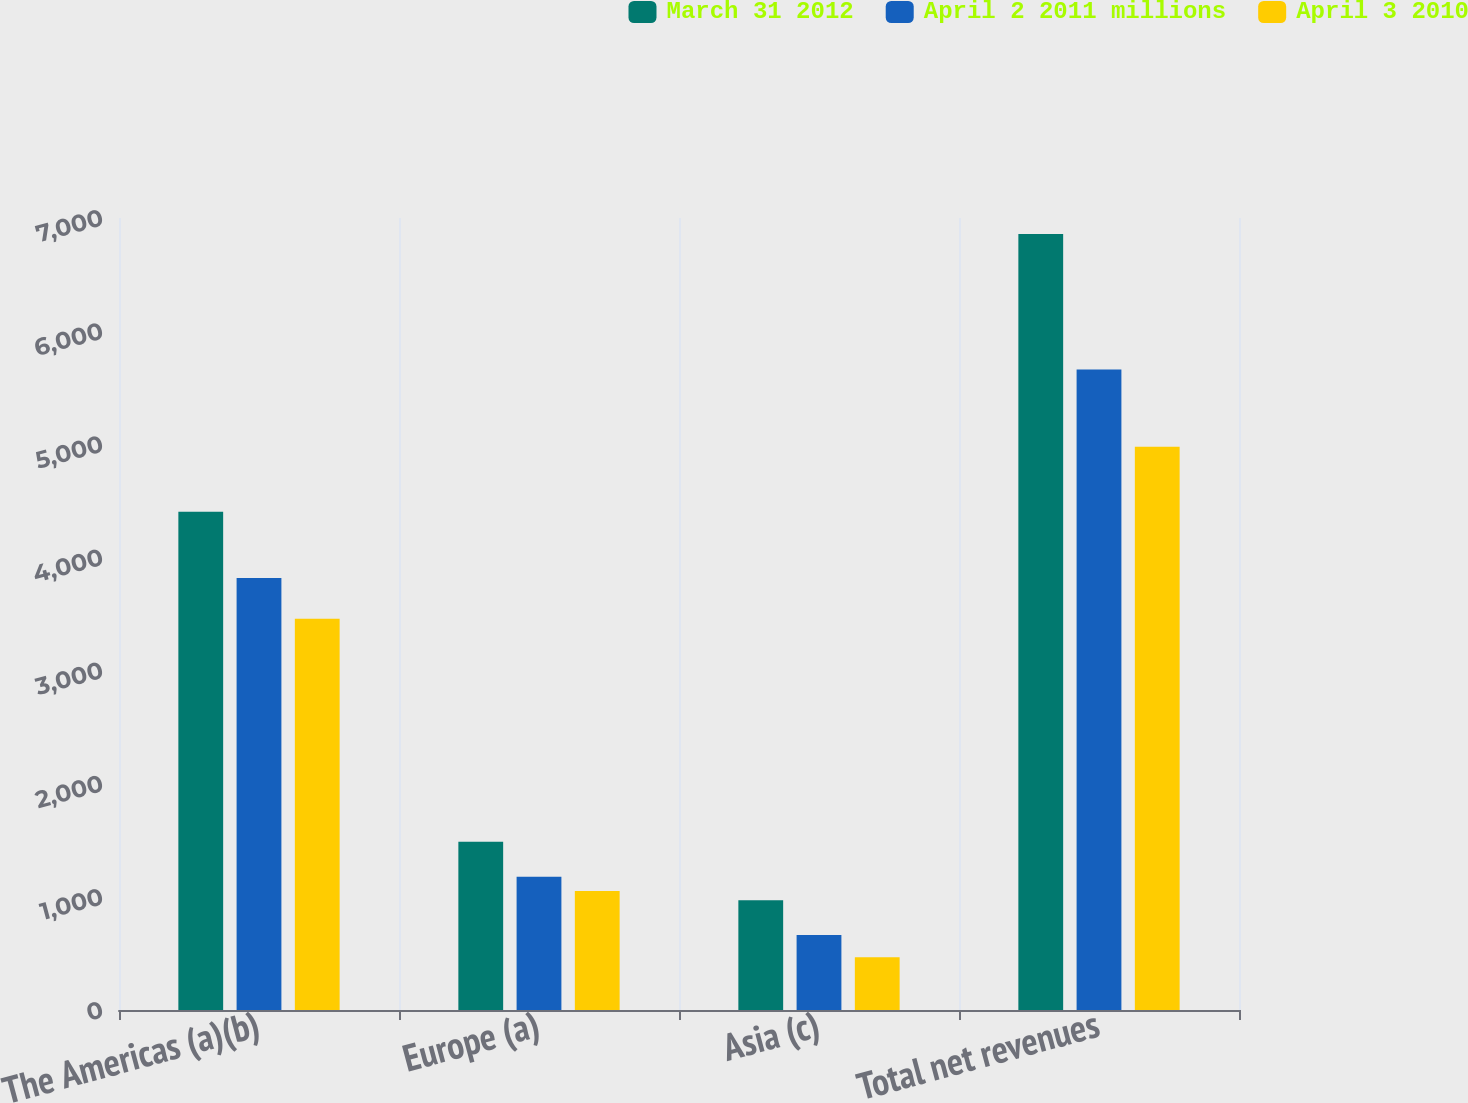Convert chart. <chart><loc_0><loc_0><loc_500><loc_500><stacked_bar_chart><ecel><fcel>The Americas (a)(b)<fcel>Europe (a)<fcel>Asia (c)<fcel>Total net revenues<nl><fcel>March 31 2012<fcel>4403<fcel>1486.5<fcel>970<fcel>6859.5<nl><fcel>April 2 2011 millions<fcel>3819.2<fcel>1178.6<fcel>662.5<fcel>5660.3<nl><fcel>April 3 2010<fcel>3459.1<fcel>1052.6<fcel>467.2<fcel>4978.9<nl></chart> 